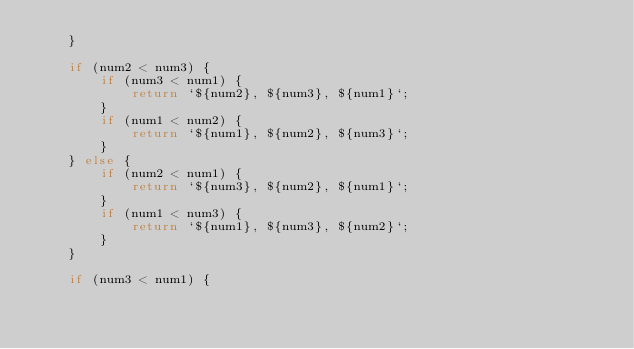Convert code to text. <code><loc_0><loc_0><loc_500><loc_500><_JavaScript_>    }
    
    if (num2 < num3) {
        if (num3 < num1) {
            return `${num2}, ${num3}, ${num1}`;
        }
        if (num1 < num2) {
            return `${num1}, ${num2}, ${num3}`;
        }
    } else {
        if (num2 < num1) {
            return `${num3}, ${num2}, ${num1}`;
        }
        if (num1 < num3) {
            return `${num1}, ${num3}, ${num2}`;
        }
    }
    
    if (num3 < num1) {</code> 